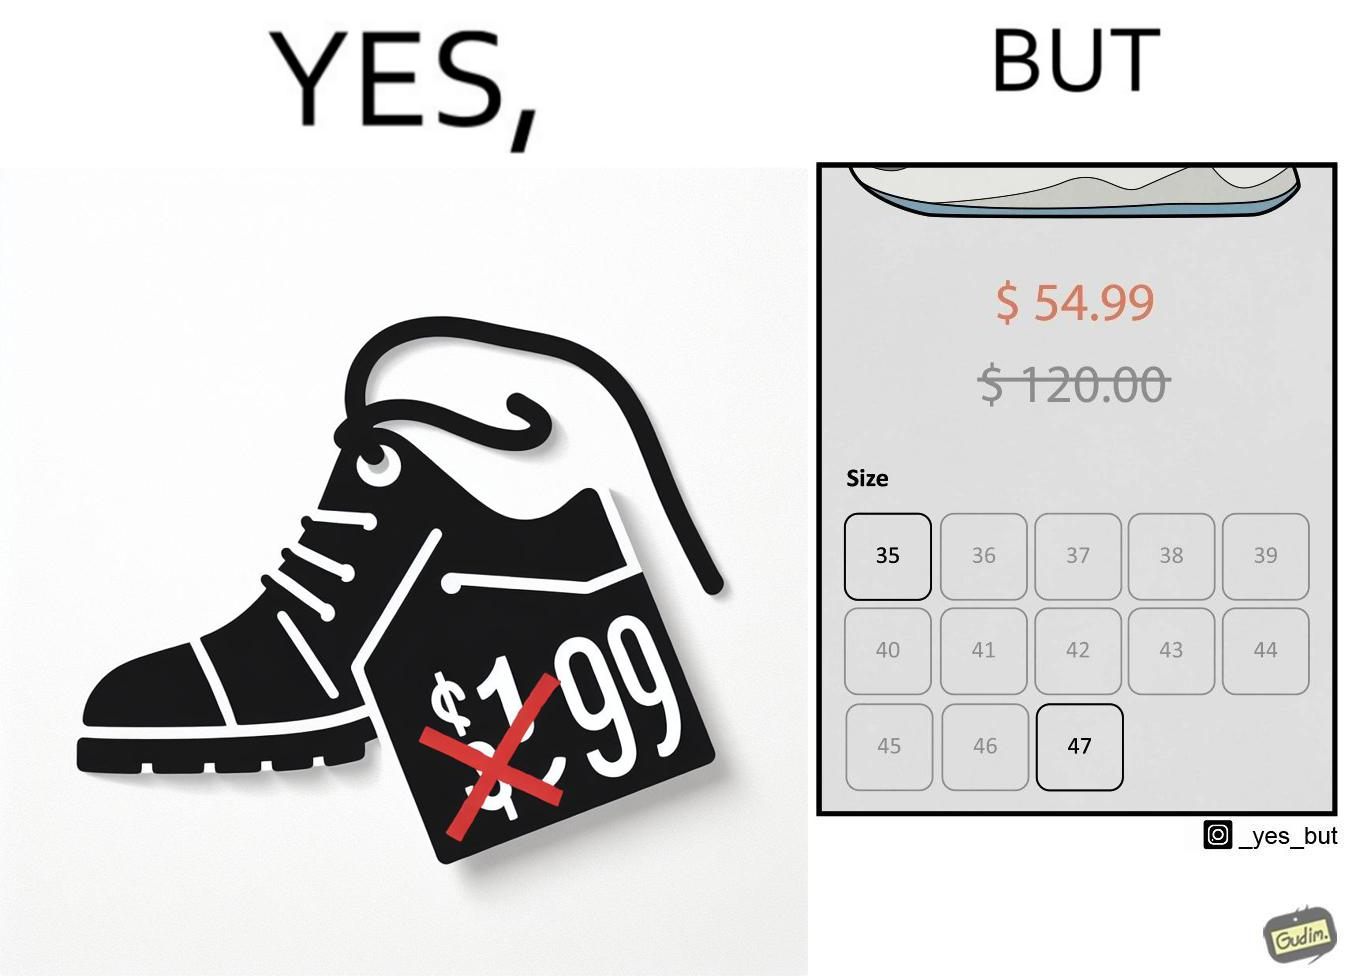Is there satirical content in this image? Yes, this image is satirical. 